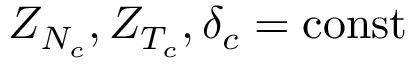<formula> <loc_0><loc_0><loc_500><loc_500>Z _ { N _ { c } } , Z _ { T _ { c } } , \delta _ { c } = { c o n s t }</formula> 